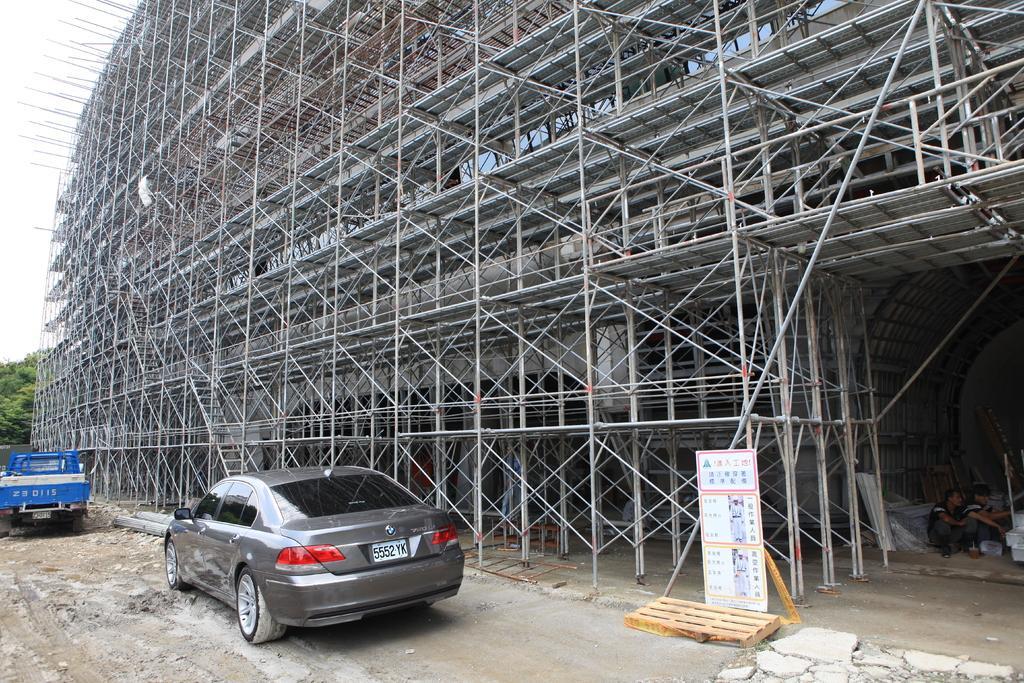Describe this image in one or two sentences. In this image on the left there is a car, and truck. This is an under constructed building. Here there is a poster. Two persons are there. In the background there are trees. 